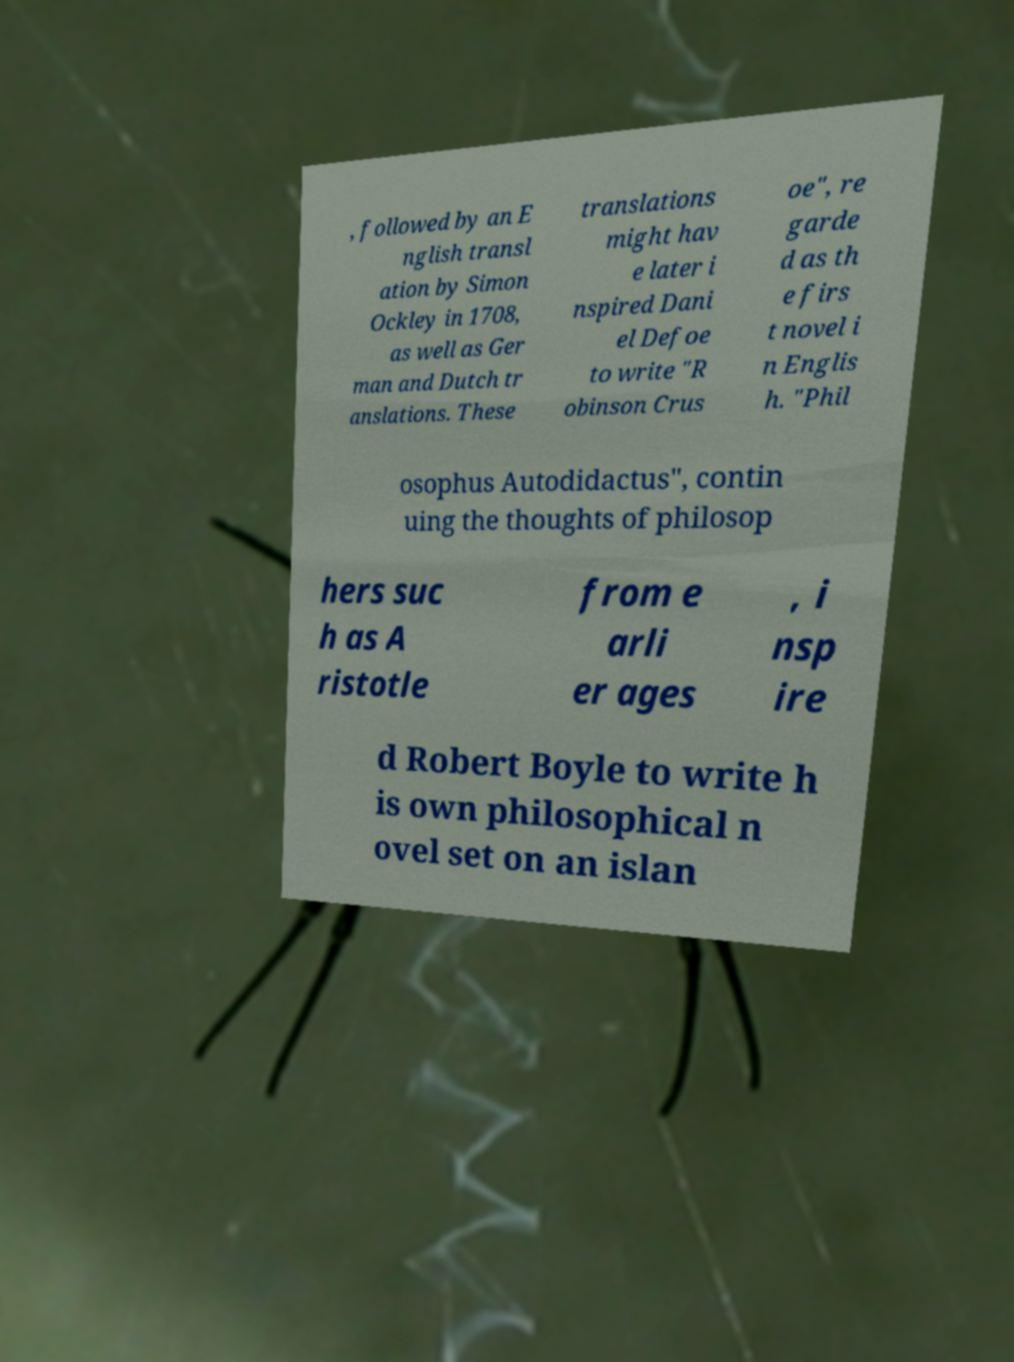Can you accurately transcribe the text from the provided image for me? , followed by an E nglish transl ation by Simon Ockley in 1708, as well as Ger man and Dutch tr anslations. These translations might hav e later i nspired Dani el Defoe to write "R obinson Crus oe", re garde d as th e firs t novel i n Englis h. "Phil osophus Autodidactus", contin uing the thoughts of philosop hers suc h as A ristotle from e arli er ages , i nsp ire d Robert Boyle to write h is own philosophical n ovel set on an islan 